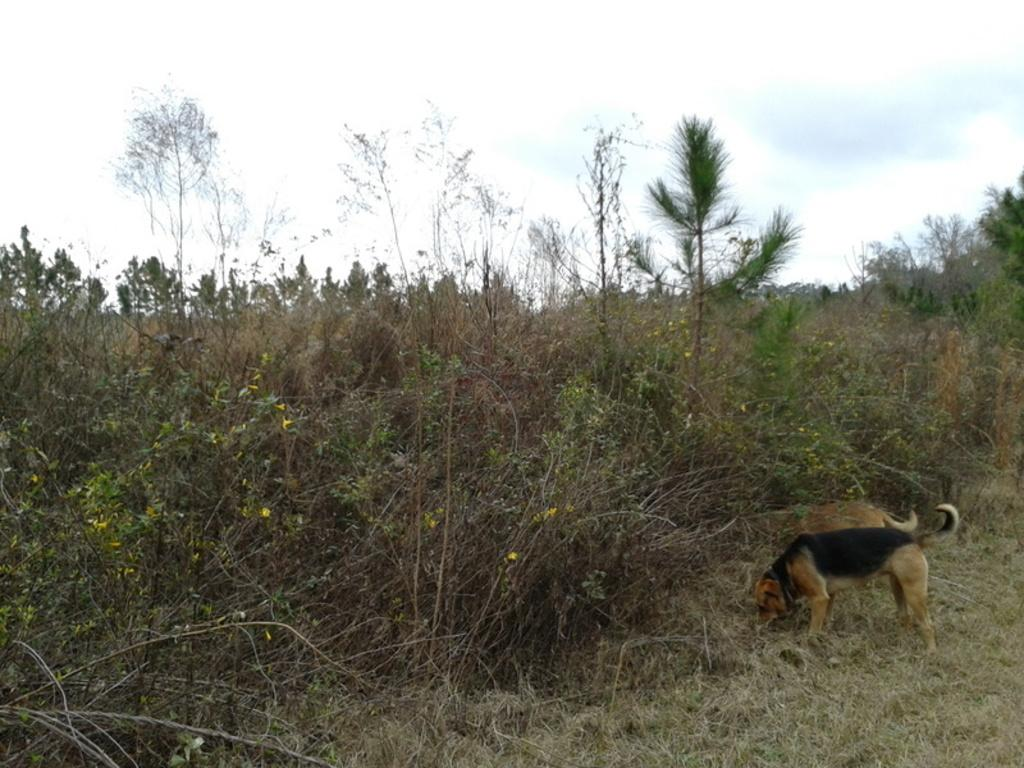What animals can be seen on the right side of the image? There are two dogs on the right side of the image. What is in front of the dogs in the image? There are plants in front of the dogs. What is visible at the top of the image? The sky is visible at the top of the image. What type of ground is present at the bottom of the image? Grass is present at the bottom of the image. What type of engine can be seen in the image? There is no engine present in the image. Can you identify the actor standing next to the dogs in the image? There is no actor present in the image; it features two dogs and plants. 